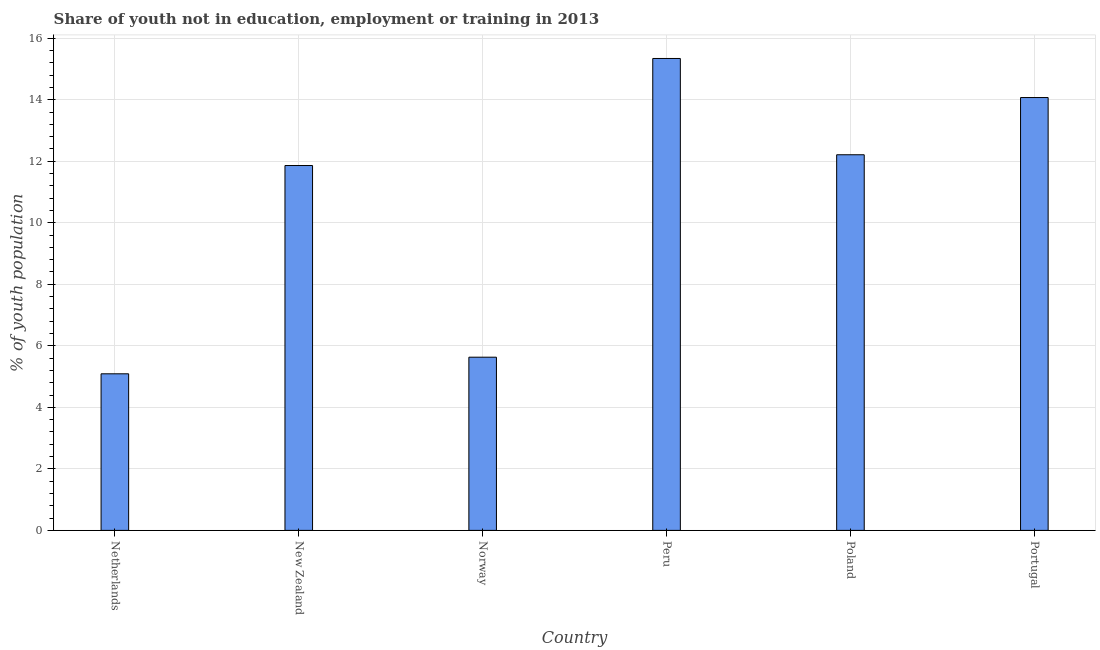Does the graph contain grids?
Your response must be concise. Yes. What is the title of the graph?
Your response must be concise. Share of youth not in education, employment or training in 2013. What is the label or title of the Y-axis?
Offer a very short reply. % of youth population. What is the unemployed youth population in Portugal?
Give a very brief answer. 14.07. Across all countries, what is the maximum unemployed youth population?
Your answer should be compact. 15.34. Across all countries, what is the minimum unemployed youth population?
Offer a terse response. 5.09. In which country was the unemployed youth population maximum?
Provide a succinct answer. Peru. In which country was the unemployed youth population minimum?
Your response must be concise. Netherlands. What is the sum of the unemployed youth population?
Provide a succinct answer. 64.2. What is the difference between the unemployed youth population in Norway and Peru?
Make the answer very short. -9.71. What is the median unemployed youth population?
Ensure brevity in your answer.  12.03. In how many countries, is the unemployed youth population greater than 12 %?
Provide a succinct answer. 3. Is the difference between the unemployed youth population in Netherlands and Portugal greater than the difference between any two countries?
Offer a terse response. No. What is the difference between the highest and the second highest unemployed youth population?
Give a very brief answer. 1.27. What is the difference between the highest and the lowest unemployed youth population?
Offer a very short reply. 10.25. In how many countries, is the unemployed youth population greater than the average unemployed youth population taken over all countries?
Your response must be concise. 4. How many bars are there?
Provide a succinct answer. 6. What is the difference between two consecutive major ticks on the Y-axis?
Provide a succinct answer. 2. Are the values on the major ticks of Y-axis written in scientific E-notation?
Your response must be concise. No. What is the % of youth population in Netherlands?
Ensure brevity in your answer.  5.09. What is the % of youth population of New Zealand?
Make the answer very short. 11.86. What is the % of youth population of Norway?
Your answer should be compact. 5.63. What is the % of youth population in Peru?
Ensure brevity in your answer.  15.34. What is the % of youth population of Poland?
Offer a very short reply. 12.21. What is the % of youth population of Portugal?
Provide a short and direct response. 14.07. What is the difference between the % of youth population in Netherlands and New Zealand?
Provide a short and direct response. -6.77. What is the difference between the % of youth population in Netherlands and Norway?
Your answer should be compact. -0.54. What is the difference between the % of youth population in Netherlands and Peru?
Provide a short and direct response. -10.25. What is the difference between the % of youth population in Netherlands and Poland?
Keep it short and to the point. -7.12. What is the difference between the % of youth population in Netherlands and Portugal?
Ensure brevity in your answer.  -8.98. What is the difference between the % of youth population in New Zealand and Norway?
Your answer should be very brief. 6.23. What is the difference between the % of youth population in New Zealand and Peru?
Keep it short and to the point. -3.48. What is the difference between the % of youth population in New Zealand and Poland?
Provide a short and direct response. -0.35. What is the difference between the % of youth population in New Zealand and Portugal?
Your answer should be compact. -2.21. What is the difference between the % of youth population in Norway and Peru?
Provide a succinct answer. -9.71. What is the difference between the % of youth population in Norway and Poland?
Offer a very short reply. -6.58. What is the difference between the % of youth population in Norway and Portugal?
Provide a short and direct response. -8.44. What is the difference between the % of youth population in Peru and Poland?
Offer a terse response. 3.13. What is the difference between the % of youth population in Peru and Portugal?
Keep it short and to the point. 1.27. What is the difference between the % of youth population in Poland and Portugal?
Offer a terse response. -1.86. What is the ratio of the % of youth population in Netherlands to that in New Zealand?
Offer a very short reply. 0.43. What is the ratio of the % of youth population in Netherlands to that in Norway?
Provide a short and direct response. 0.9. What is the ratio of the % of youth population in Netherlands to that in Peru?
Your answer should be very brief. 0.33. What is the ratio of the % of youth population in Netherlands to that in Poland?
Provide a succinct answer. 0.42. What is the ratio of the % of youth population in Netherlands to that in Portugal?
Ensure brevity in your answer.  0.36. What is the ratio of the % of youth population in New Zealand to that in Norway?
Your response must be concise. 2.11. What is the ratio of the % of youth population in New Zealand to that in Peru?
Your response must be concise. 0.77. What is the ratio of the % of youth population in New Zealand to that in Portugal?
Ensure brevity in your answer.  0.84. What is the ratio of the % of youth population in Norway to that in Peru?
Give a very brief answer. 0.37. What is the ratio of the % of youth population in Norway to that in Poland?
Your answer should be compact. 0.46. What is the ratio of the % of youth population in Peru to that in Poland?
Provide a short and direct response. 1.26. What is the ratio of the % of youth population in Peru to that in Portugal?
Offer a terse response. 1.09. What is the ratio of the % of youth population in Poland to that in Portugal?
Give a very brief answer. 0.87. 